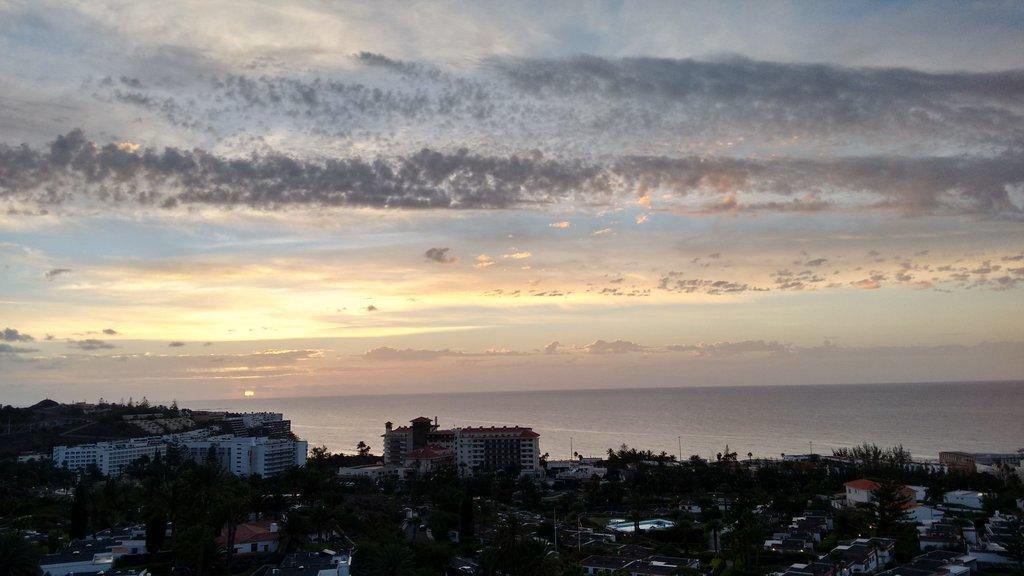How would you summarize this image in a sentence or two? Here in this picture we can see buildings and houses present on the ground all over there and we can also see trees and plants present here and there and in the far we can see water present all over there and we can see a sunset and we can also see clouds in the sky. 